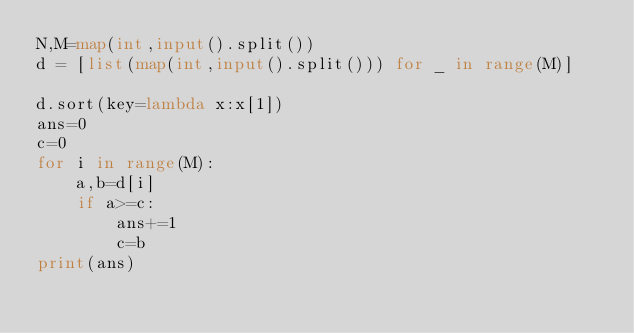Convert code to text. <code><loc_0><loc_0><loc_500><loc_500><_Python_>N,M=map(int,input().split())
d = [list(map(int,input().split())) for _ in range(M)]

d.sort(key=lambda x:x[1])
ans=0
c=0
for i in range(M):
    a,b=d[i]
    if a>=c:
        ans+=1
        c=b
print(ans)

</code> 